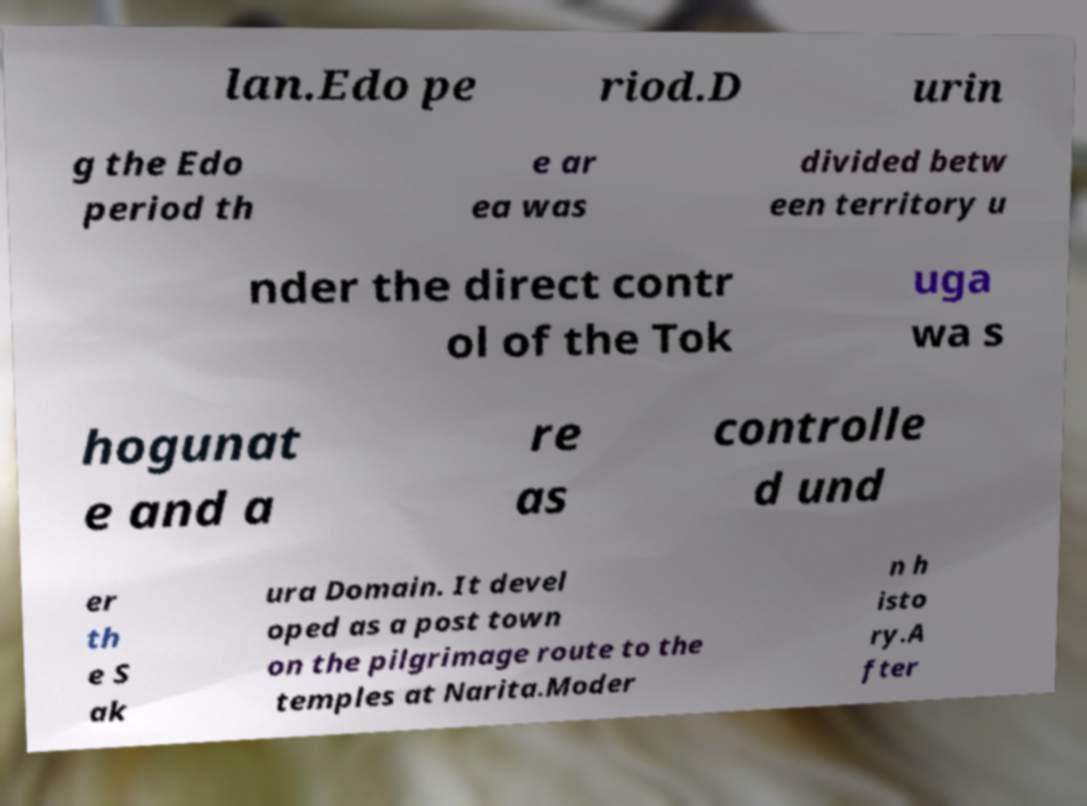Please identify and transcribe the text found in this image. lan.Edo pe riod.D urin g the Edo period th e ar ea was divided betw een territory u nder the direct contr ol of the Tok uga wa s hogunat e and a re as controlle d und er th e S ak ura Domain. It devel oped as a post town on the pilgrimage route to the temples at Narita.Moder n h isto ry.A fter 